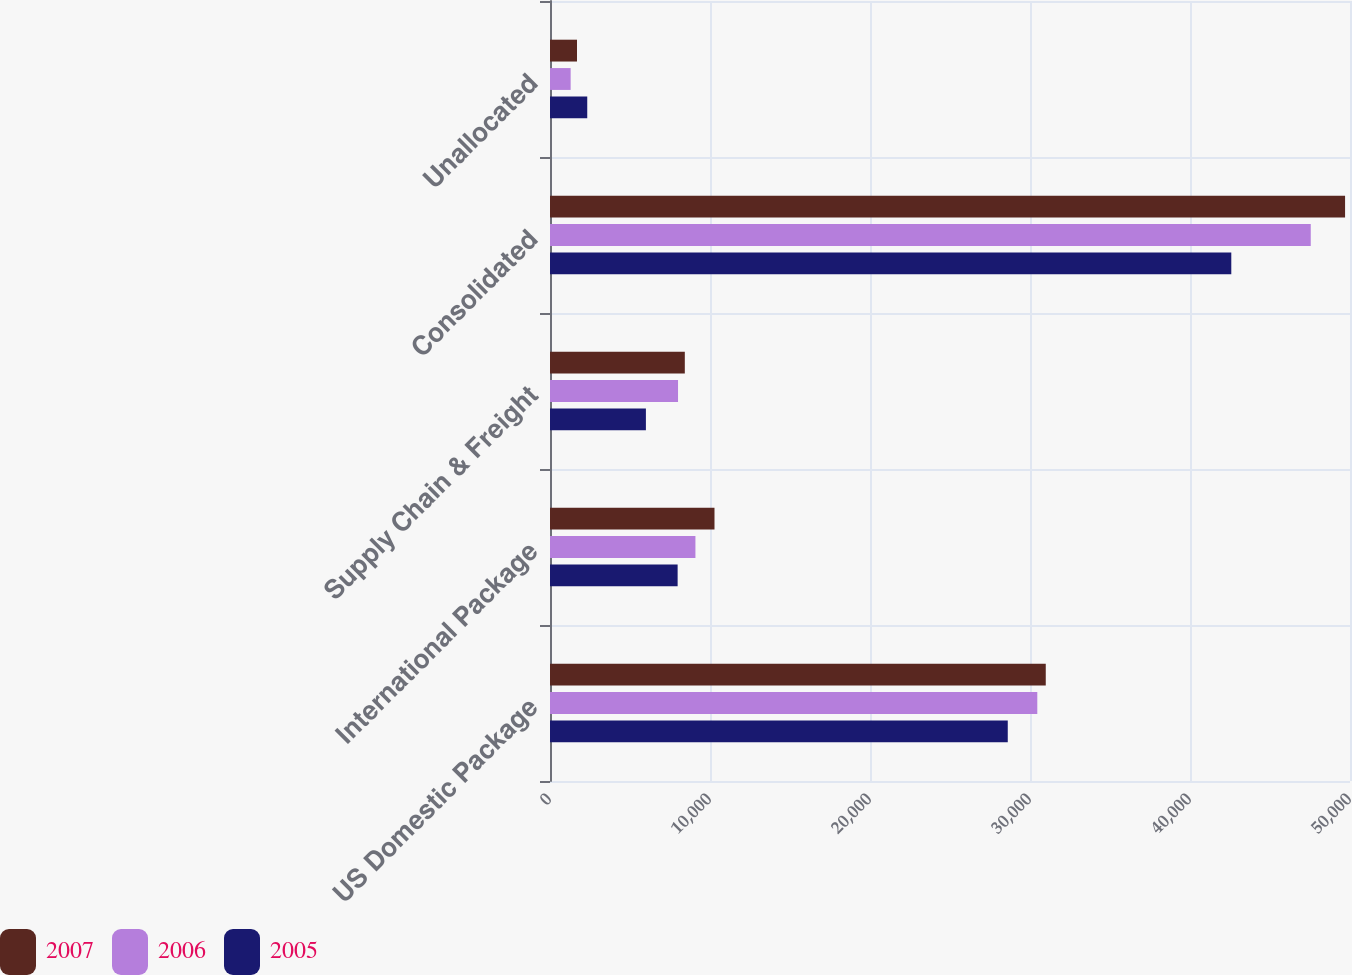<chart> <loc_0><loc_0><loc_500><loc_500><stacked_bar_chart><ecel><fcel>US Domestic Package<fcel>International Package<fcel>Supply Chain & Freight<fcel>Consolidated<fcel>Unallocated<nl><fcel>2007<fcel>30985<fcel>10281<fcel>8426<fcel>49692<fcel>1686<nl><fcel>2006<fcel>30456<fcel>9089<fcel>8002<fcel>47547<fcel>1290<nl><fcel>2005<fcel>28610<fcel>7977<fcel>5994<fcel>42581<fcel>2328<nl></chart> 